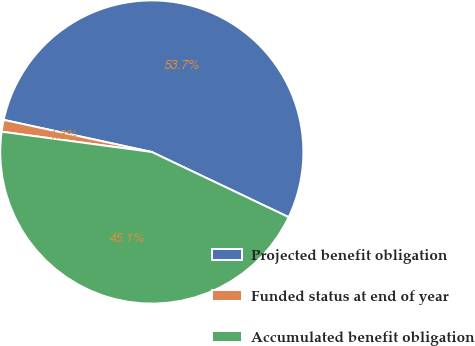Convert chart to OTSL. <chart><loc_0><loc_0><loc_500><loc_500><pie_chart><fcel>Projected benefit obligation<fcel>Funded status at end of year<fcel>Accumulated benefit obligation<nl><fcel>53.67%<fcel>1.26%<fcel>45.07%<nl></chart> 